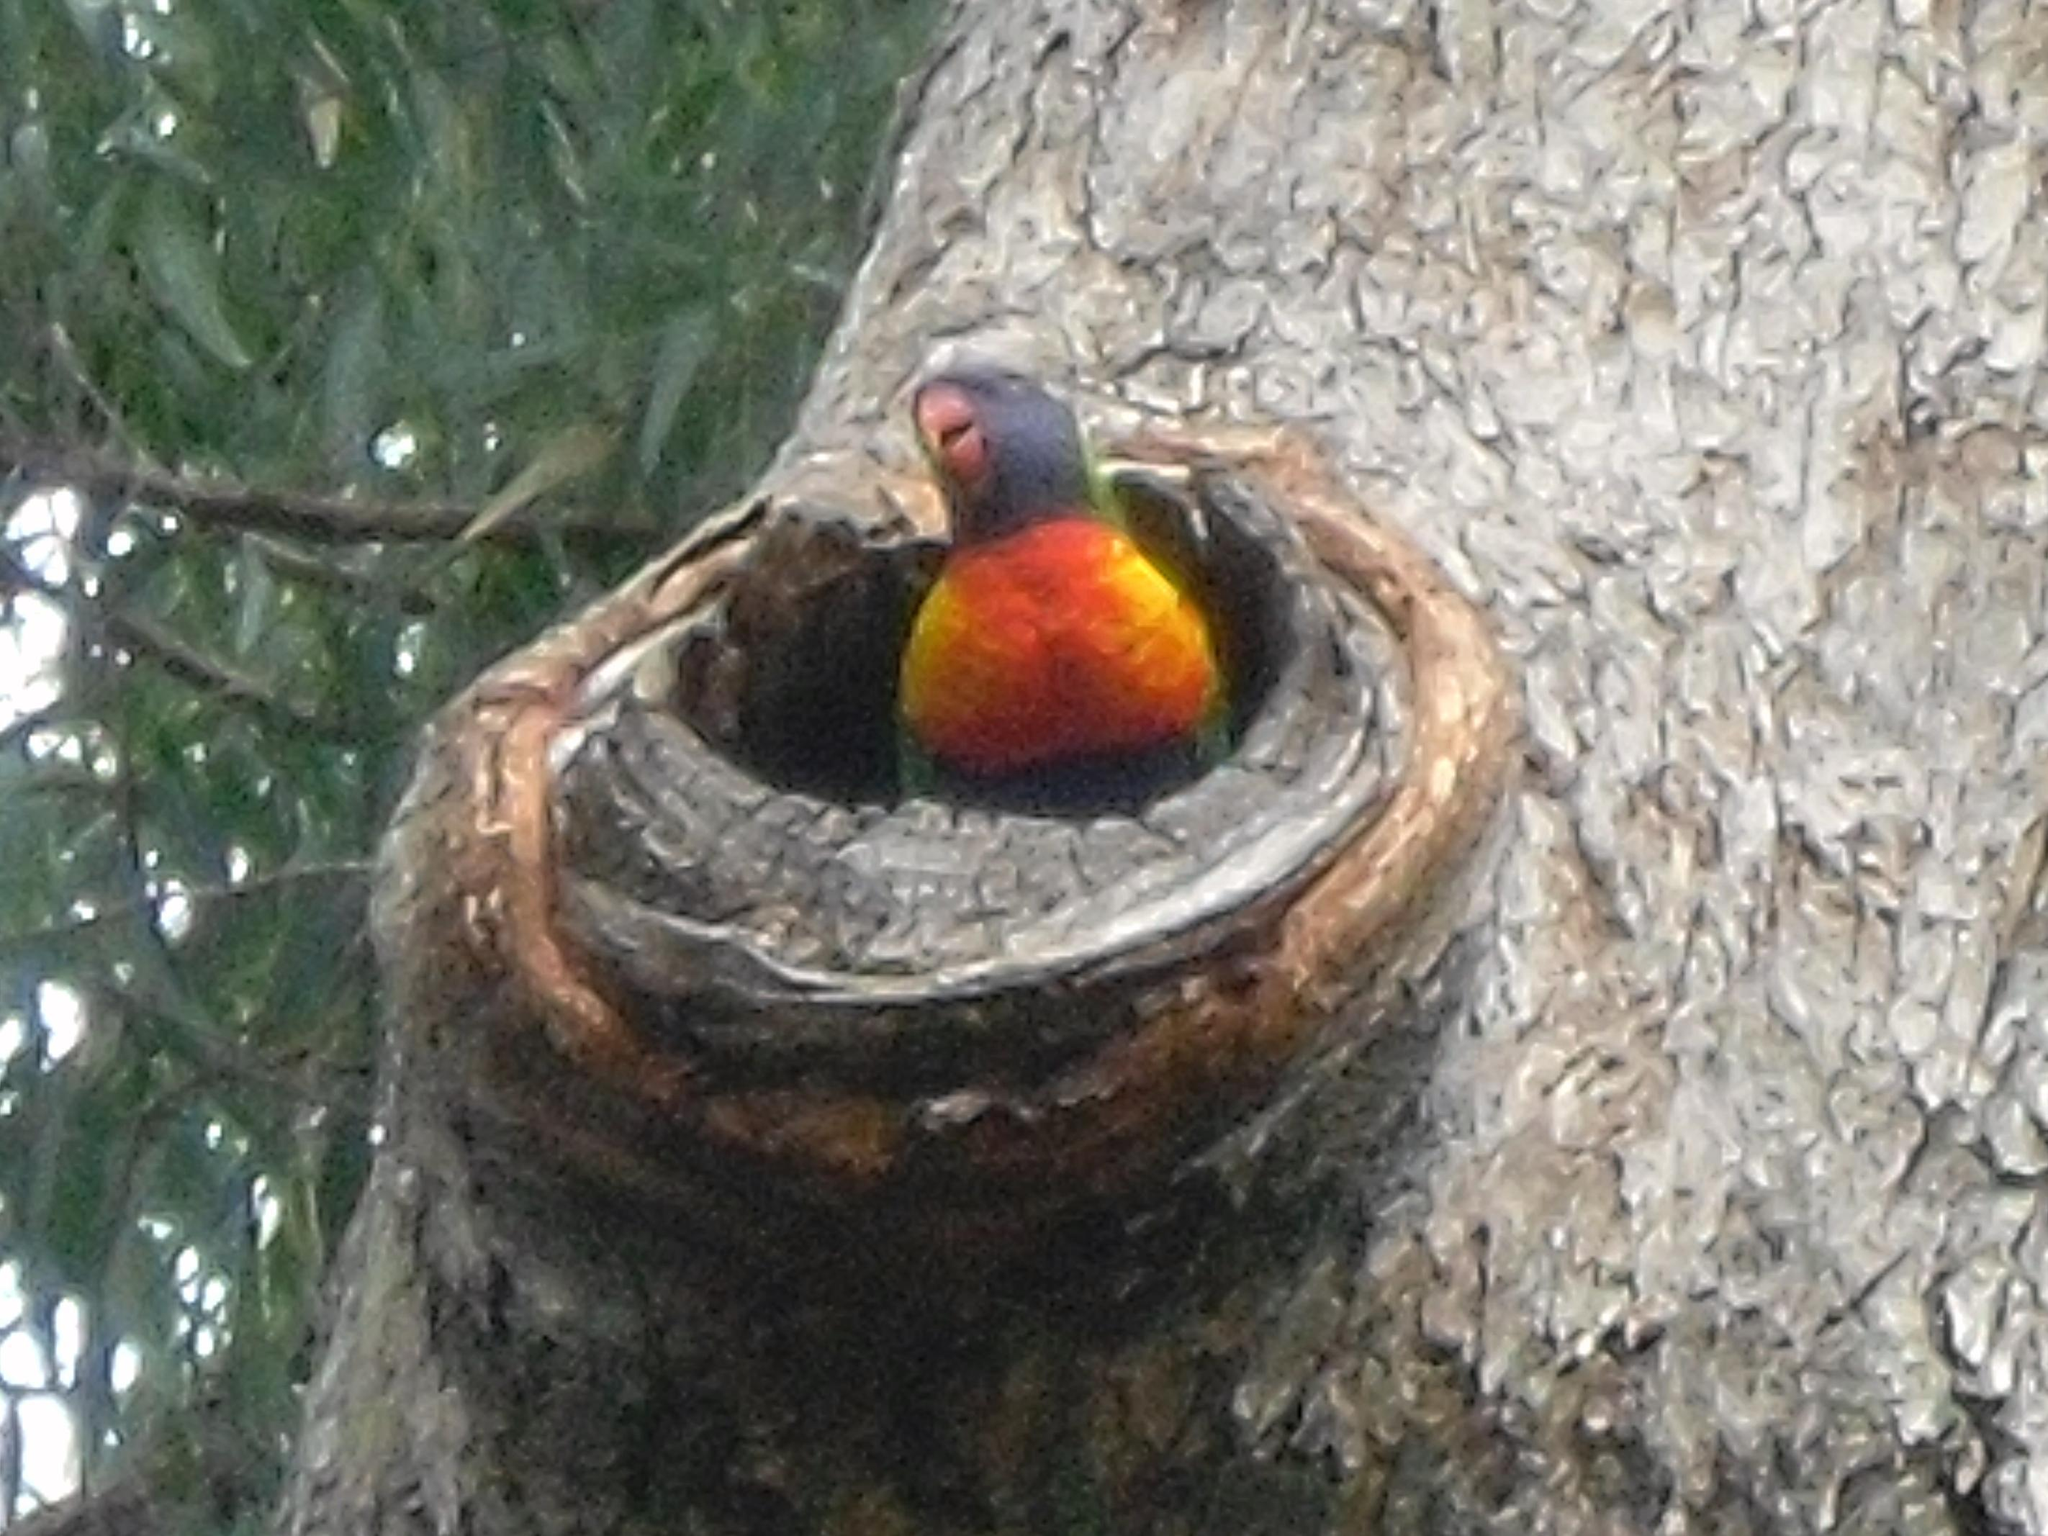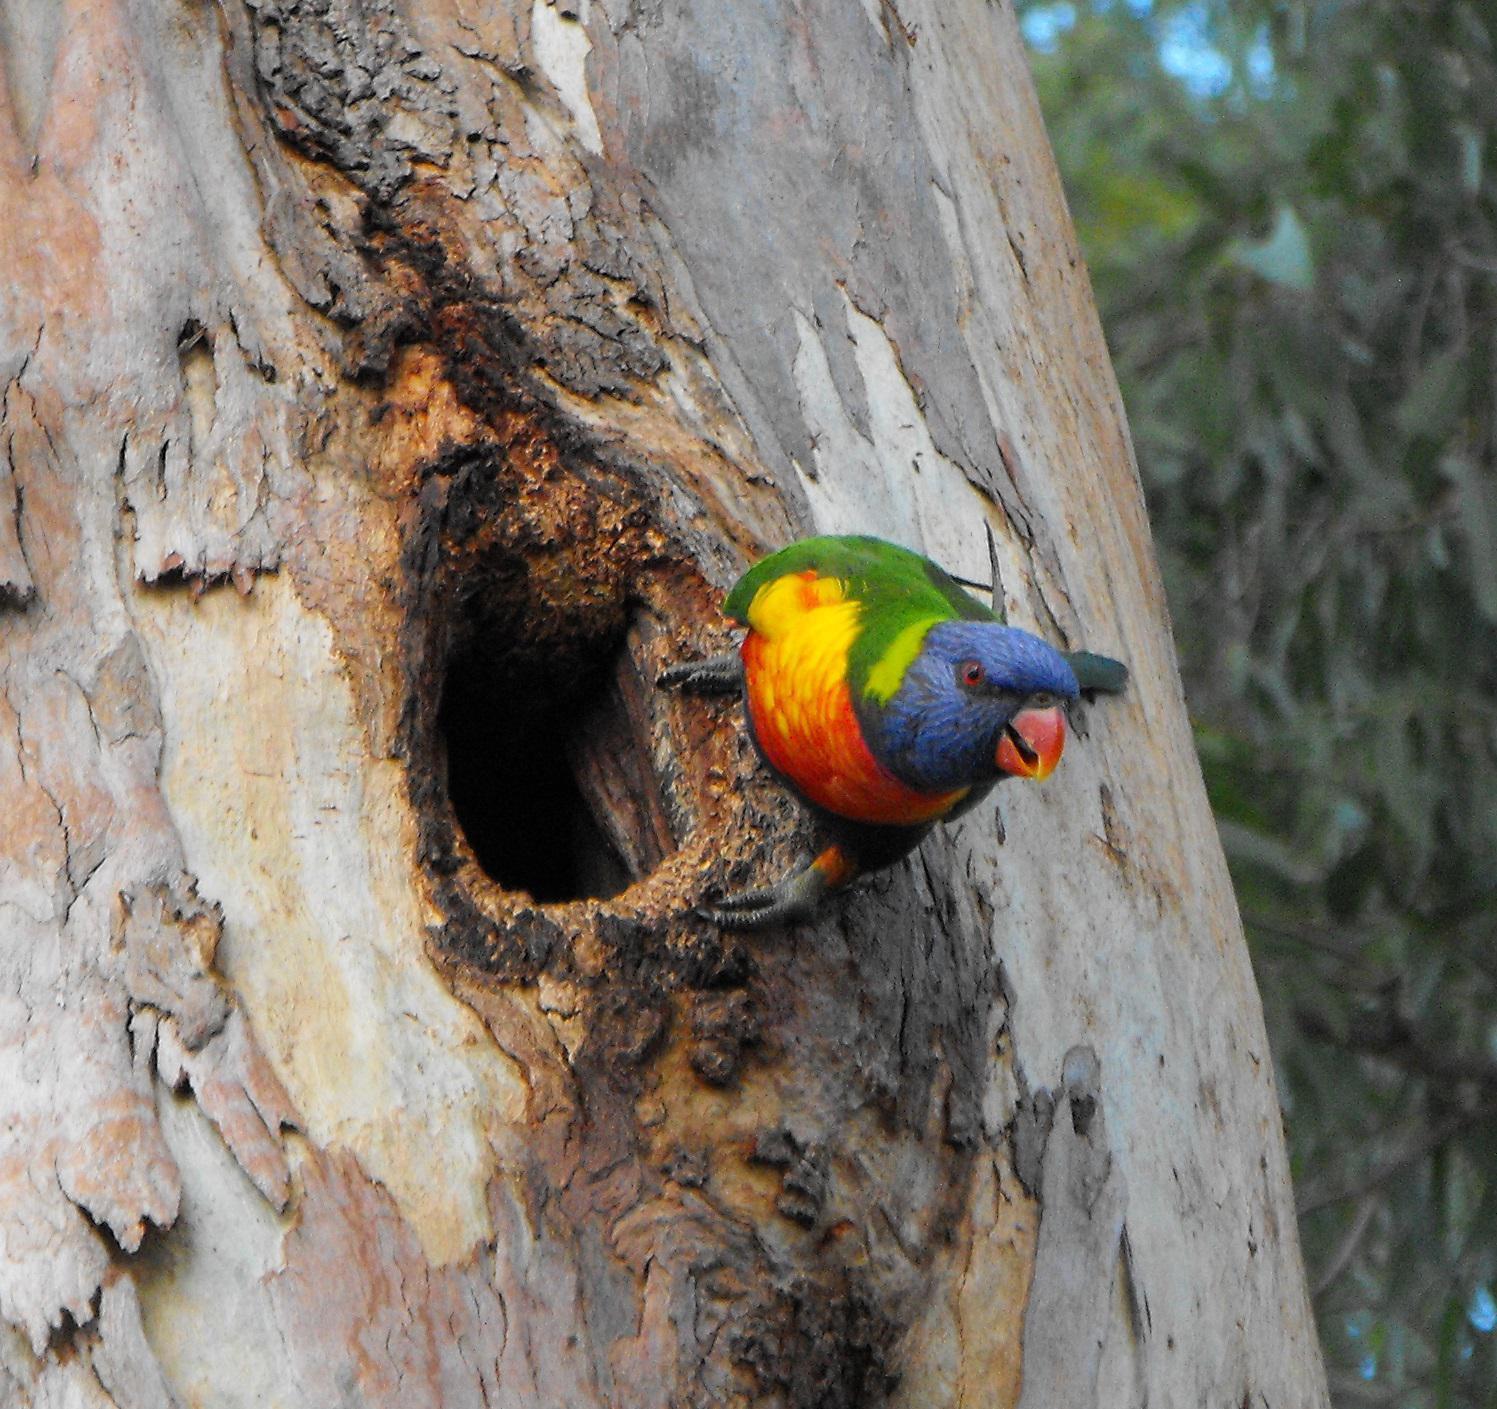The first image is the image on the left, the second image is the image on the right. For the images displayed, is the sentence "Left and right images each show no more than two birds, and all images show a bird near a hollow in a tree." factually correct? Answer yes or no. Yes. The first image is the image on the left, the second image is the image on the right. Assess this claim about the two images: "The right image contains at least three parrots.". Correct or not? Answer yes or no. No. 